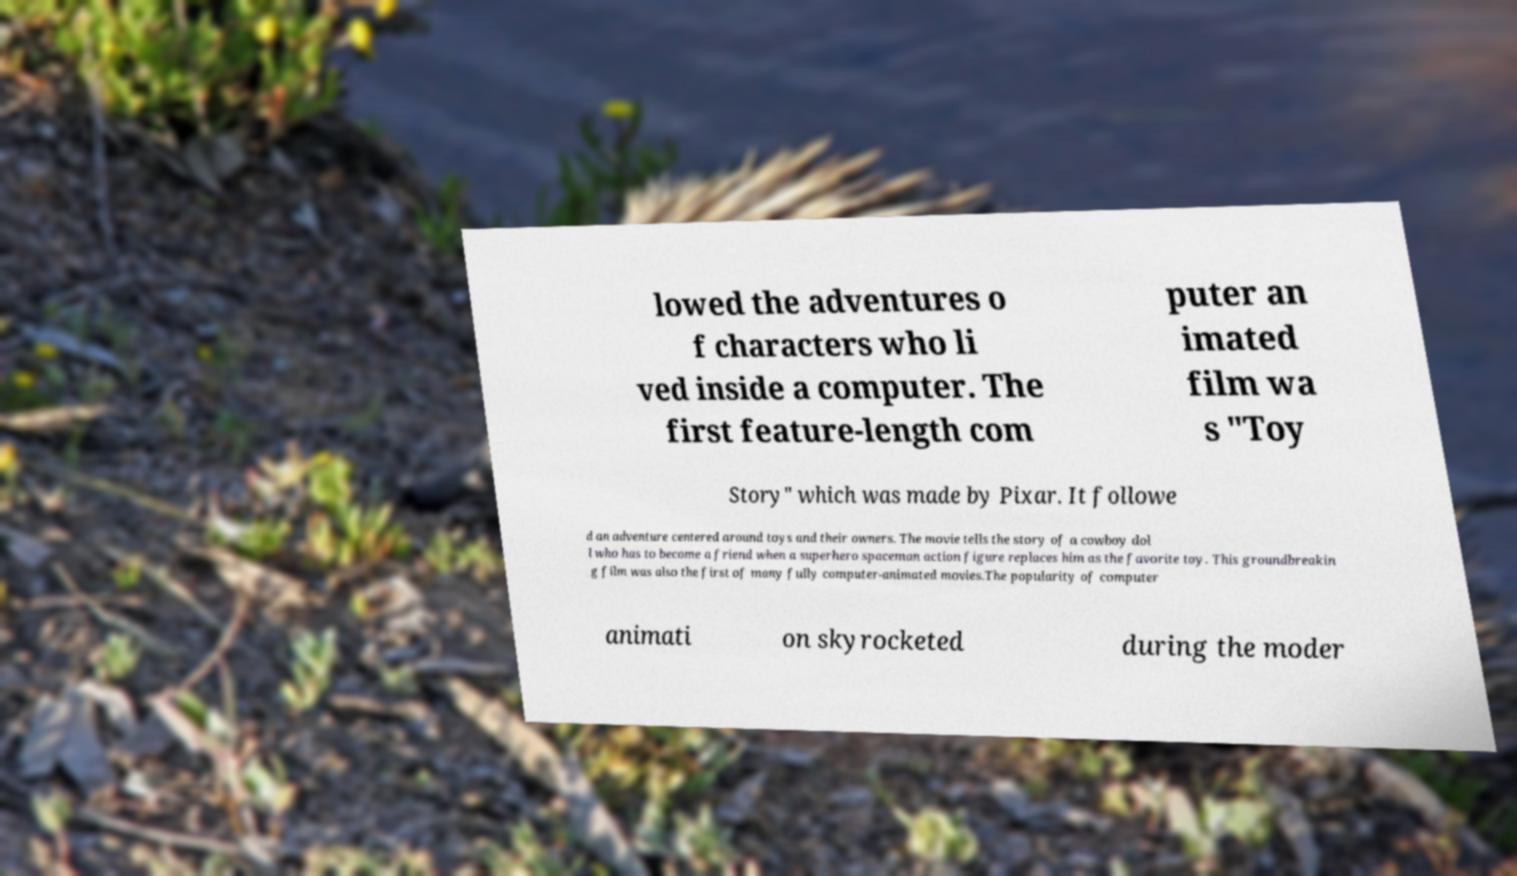I need the written content from this picture converted into text. Can you do that? lowed the adventures o f characters who li ved inside a computer. The first feature-length com puter an imated film wa s "Toy Story" which was made by Pixar. It followe d an adventure centered around toys and their owners. The movie tells the story of a cowboy dol l who has to become a friend when a superhero spaceman action figure replaces him as the favorite toy. This groundbreakin g film was also the first of many fully computer-animated movies.The popularity of computer animati on skyrocketed during the moder 